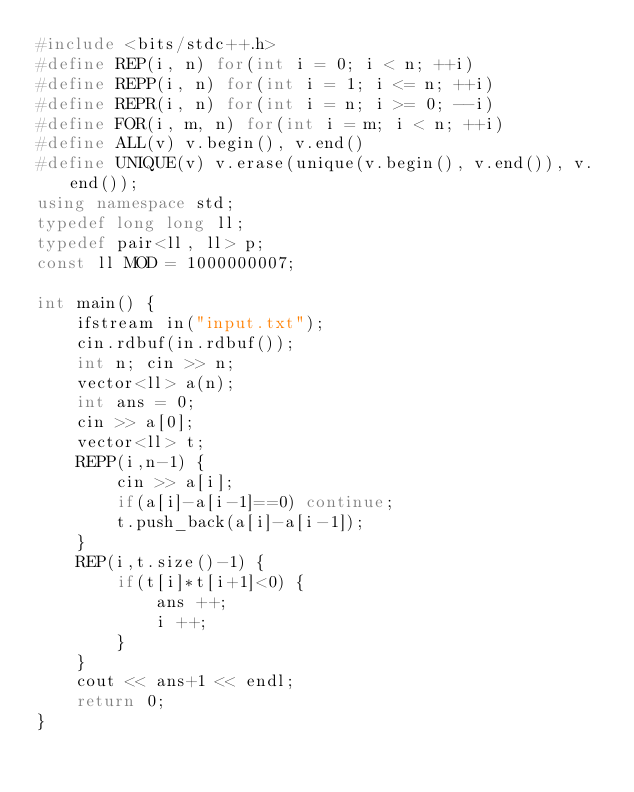Convert code to text. <code><loc_0><loc_0><loc_500><loc_500><_C++_>#include <bits/stdc++.h>
#define REP(i, n) for(int i = 0; i < n; ++i)
#define REPP(i, n) for(int i = 1; i <= n; ++i)
#define REPR(i, n) for(int i = n; i >= 0; --i)
#define FOR(i, m, n) for(int i = m; i < n; ++i)
#define ALL(v) v.begin(), v.end()
#define UNIQUE(v) v.erase(unique(v.begin(), v.end()), v.end());
using namespace std;
typedef long long ll;
typedef pair<ll, ll> p;
const ll MOD = 1000000007;

int main() {
    ifstream in("input.txt");
    cin.rdbuf(in.rdbuf());
    int n; cin >> n;
    vector<ll> a(n);
    int ans = 0;
    cin >> a[0];
    vector<ll> t;
    REPP(i,n-1) {
        cin >> a[i];
        if(a[i]-a[i-1]==0) continue;
        t.push_back(a[i]-a[i-1]);
    }
    REP(i,t.size()-1) {
        if(t[i]*t[i+1]<0) {
            ans ++;
            i ++;
        }
    }
    cout << ans+1 << endl;
    return 0;
}</code> 